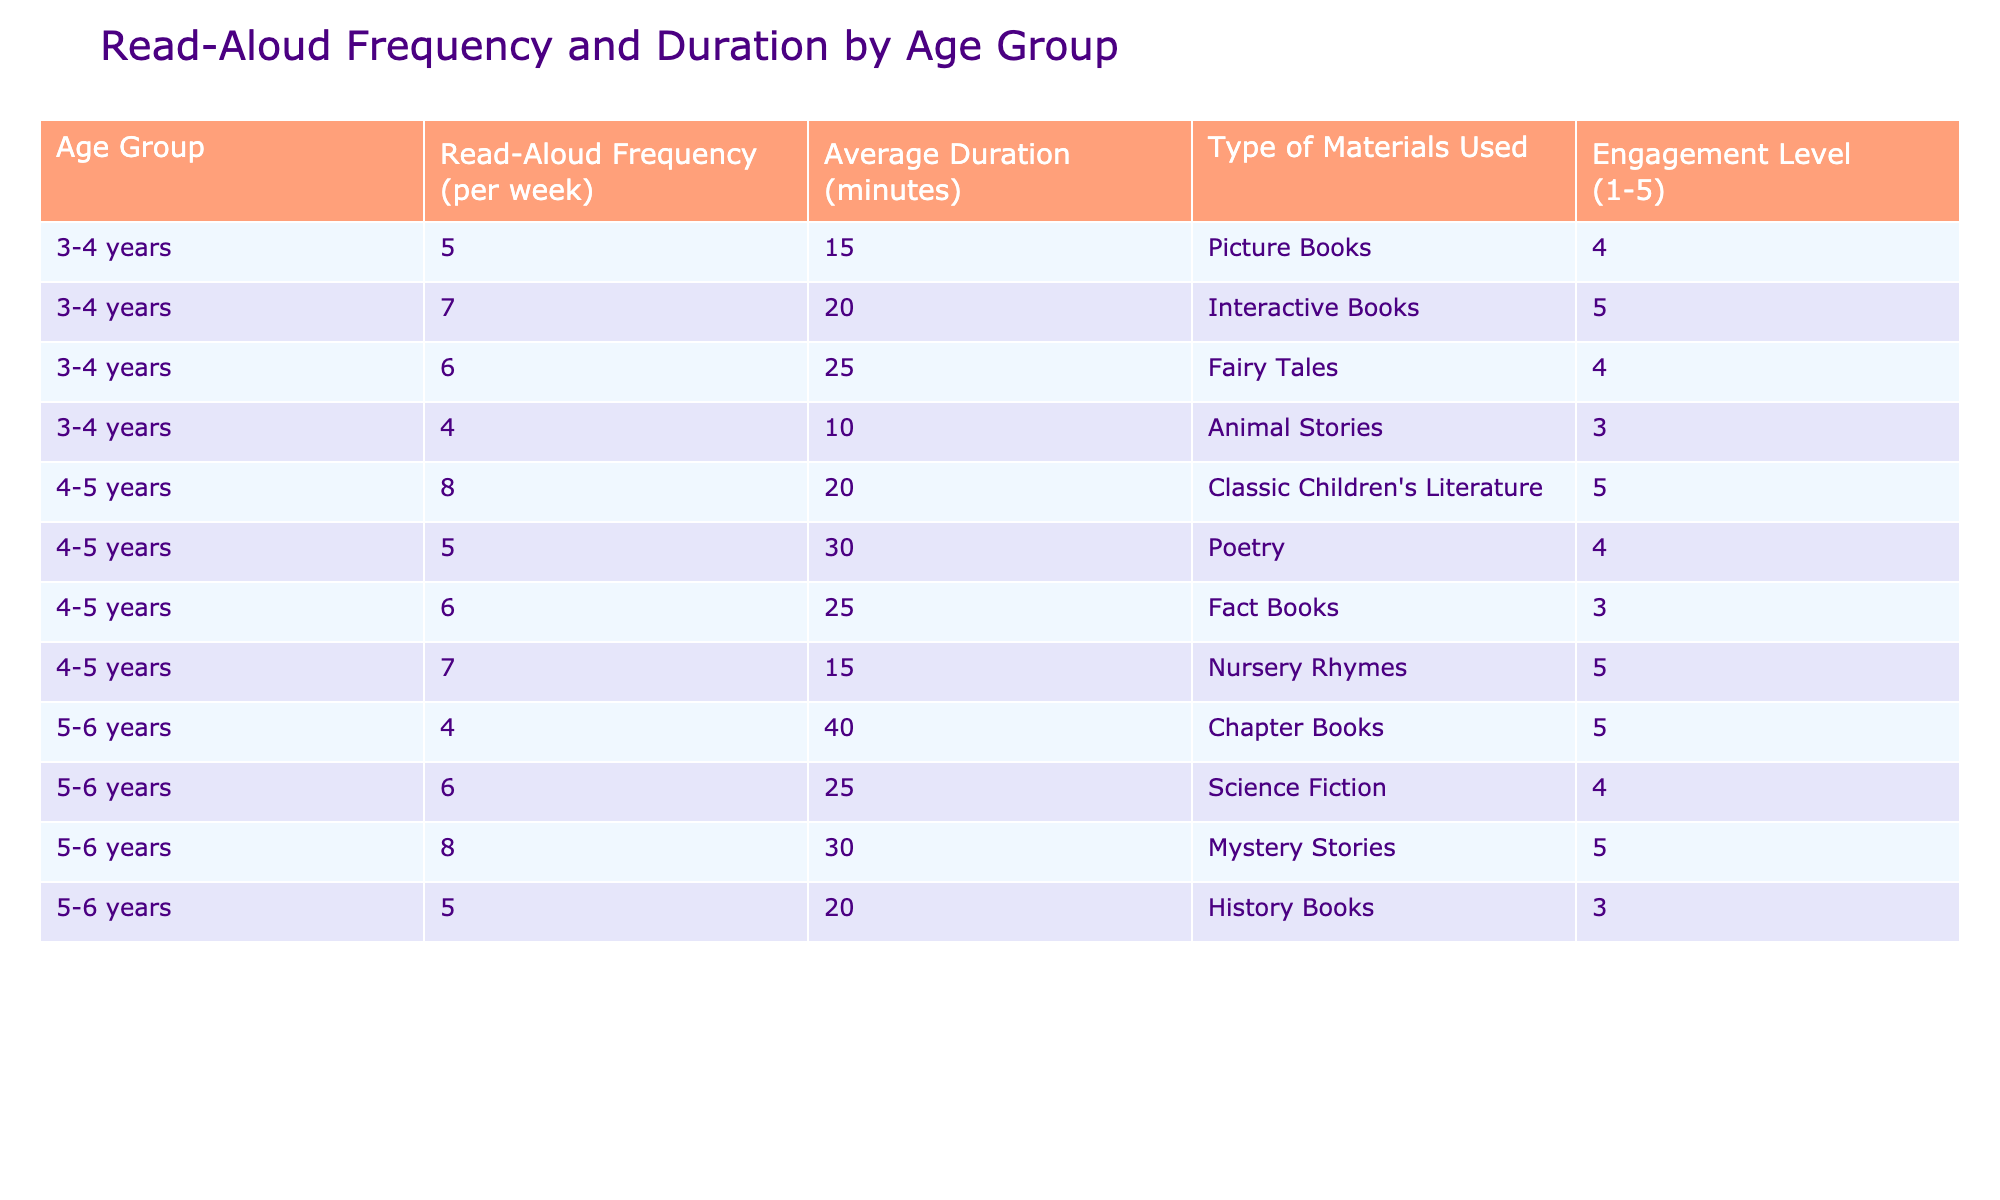What is the average read-aloud frequency for the 4-5 years age group? The frequency values for the 4-5 years age group are 8, 5, 6, and 7. Summing these values gives 8 + 5 + 6 + 7 = 26. There are 4 data points, so dividing 26 by 4 gives an average of 6.5.
Answer: 6.5 What type of materials have the highest engagement level for 3-4 years? In the 3-4 years age group, the engagement levels for each type of material are: Picture Books (4), Interactive Books (5), Fairy Tales (4), and Animal Stories (3). The highest engagement level is 5, corresponding to Interactive Books.
Answer: Interactive Books How does the average duration of read-aloud sessions compare between the 5-6 years and 3-4 years age groups? The average duration for 5-6 years is (40 + 25 + 30 + 20) / 4 = 26.25 minutes, while for 3-4 years it is (15 + 20 + 25 + 10) / 4 = 17.5 minutes. Thus, 26.25 is greater than 17.5.
Answer: 5-6 years has longer durations Is the engagement level for Fact Books in the 4-5 years age group less than 4? The engagement level for Fact Books in the 4-5 years age group is 3, which is indeed less than 4.
Answer: Yes What is the total read-aloud frequency for all age groups combined? The frequencies for each age group are summed as follows: 5 + 7 + 6 + 4 (for 3-4 years) = 22, 8 + 5 + 6 + 7 (for 4-5 years) = 26, and 4 + 6 + 8 + 5 (for 5-6 years) = 23. Adding these gives 22 + 26 + 23 = 71.
Answer: 71 What is the highest average duration of read-aloud sessions among all age groups? The average durations are 17.5 minutes for 3-4 years, 23.75 minutes for 4-5 years, and 28.75 minutes for 5-6 years. The highest average is 28.75 minutes for the 5-6 years age group.
Answer: 5-6 years age group Are children aged 4-5 years shown to listen to more Classic Children's Literature or Poetry? The frequency for Classic Children's Literature is 8 and for Poetry is 5. Since 8 is greater than 5, they listen to more Classic Children's Literature.
Answer: Classic Children's Literature What is the difference in the average engagement level between Interactive Books and Animal Stories for the 3-4 years age group? The engagement level for Interactive Books is 5 and for Animal Stories is 3. The difference is 5 - 3 = 2.
Answer: 2 Which type of material in the 5-6 years age group has the lowest average engagement level? The engagement levels for 5-6 years are: Chapter Books (5), Science Fiction (4), Mystery Stories (5), and History Books (3). The lowest is 3 for History Books.
Answer: History Books What percentage of sessions for 3-4 years use Interactive Books, given the total weekly frequency is 22? The frequency for Interactive Books for 3-4 years is 7. To find the percentage, (7 / 22) * 100 = 31.82%.
Answer: 31.82% 